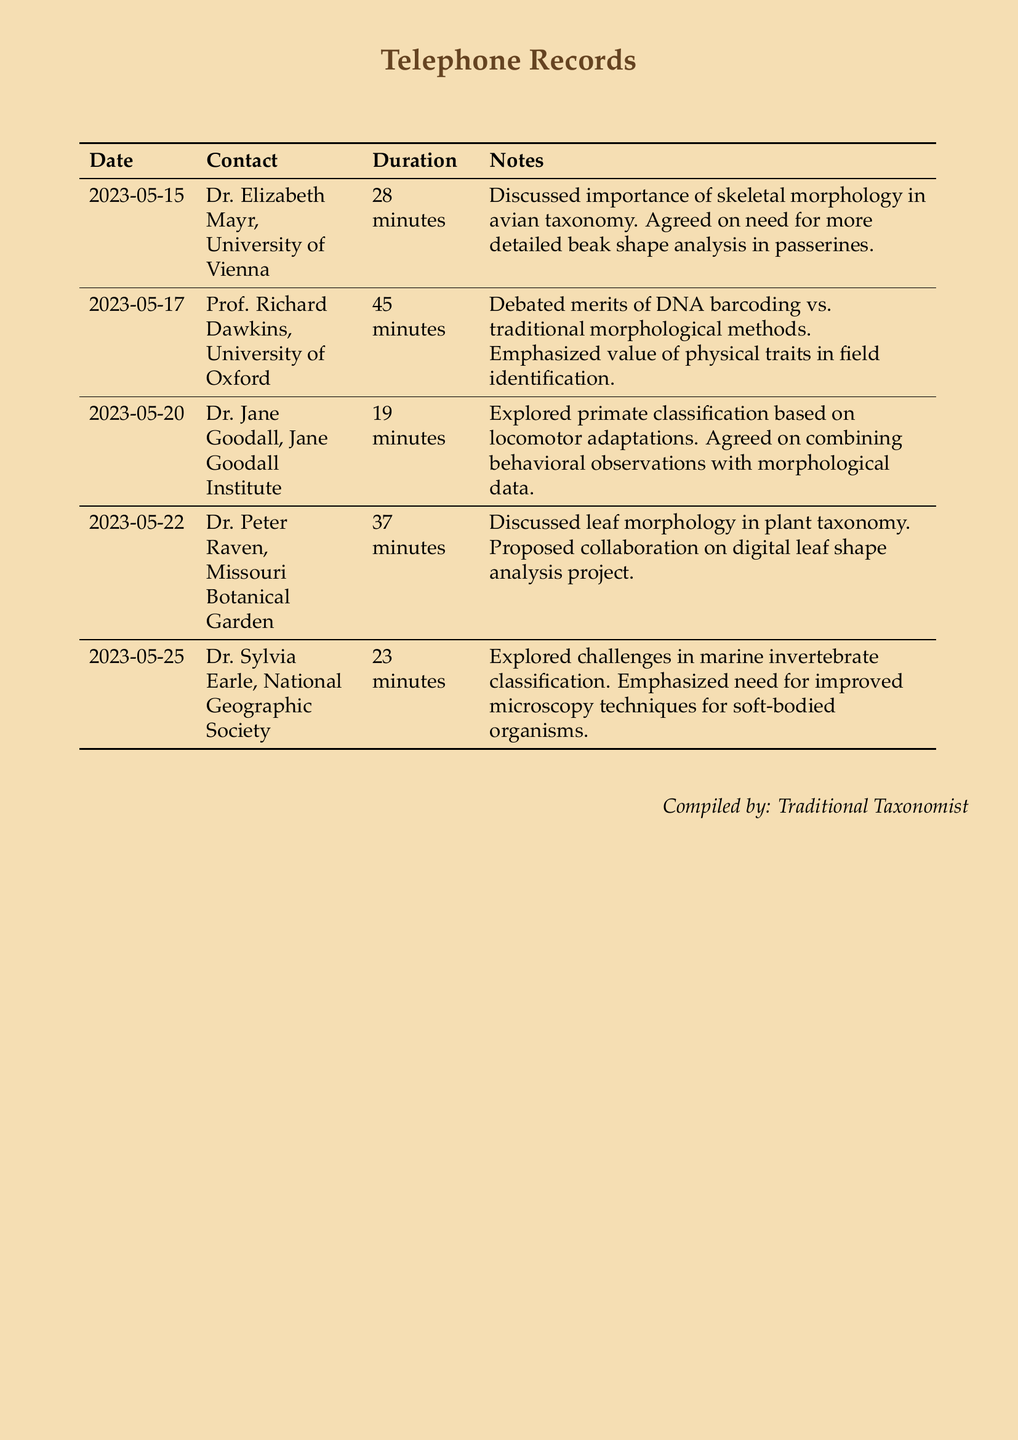What is the duration of the call with Dr. Elizabeth Mayr? The duration of the call is explicitly mentioned in the record for Dr. Elizabeth Mayr, which is 28 minutes.
Answer: 28 minutes What topic did you discuss with Prof. Richard Dawkins? The notes for the call with Prof. Richard Dawkins indicate a debate about DNA barcoding vs. traditional morphological methods.
Answer: DNA barcoding vs. traditional morphological methods On what date did you converse with Dr. Jane Goodall? The date for the call with Dr. Jane Goodall is clearly listed in the telephone records, which is 2023-05-20.
Answer: 2023-05-20 How long was the call with Dr. Peter Raven? The call duration with Dr. Peter Raven is specified in the document, which is 37 minutes.
Answer: 37 minutes What was emphasized by Dr. Sylvia Earle during your conversation? The notes for the call with Dr. Sylvia Earle highlight the need for improved microscopy techniques for soft-bodied organisms.
Answer: Improved microscopy techniques for soft-bodied organisms Which taxonomy method did you discuss with Dr. Elizabeth Mayr? The conversation with Dr. Elizabeth Mayr focused on skeletal morphology in avian taxonomy.
Answer: Skeletal morphology in avian taxonomy What is the relationship between behavior and morphology discussed with Dr. Jane Goodall? The conversation included combining behavioral observations with morphological data for classification.
Answer: Combining behavioral observations with morphological data What collaboration was proposed during the call with Dr. Peter Raven? The discussion with Dr. Peter Raven included a proposal for a digital leaf shape analysis project.
Answer: Digital leaf shape analysis project 